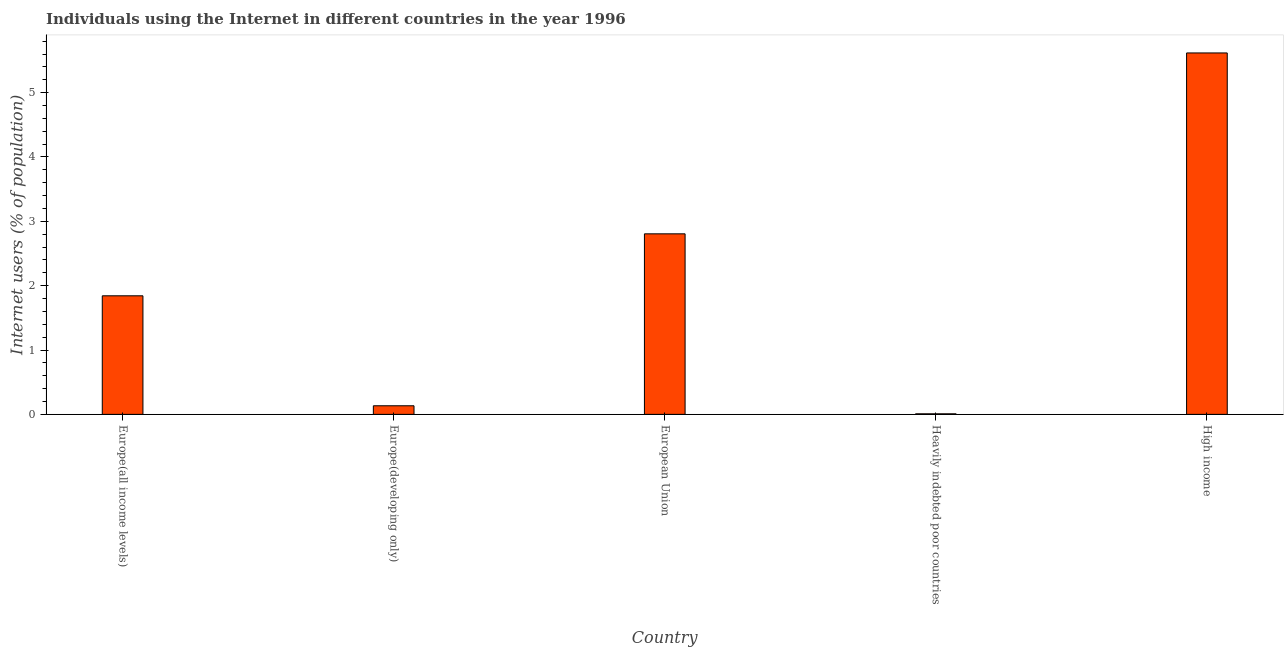Does the graph contain any zero values?
Make the answer very short. No. Does the graph contain grids?
Offer a terse response. No. What is the title of the graph?
Provide a short and direct response. Individuals using the Internet in different countries in the year 1996. What is the label or title of the Y-axis?
Provide a short and direct response. Internet users (% of population). What is the number of internet users in High income?
Your answer should be compact. 5.62. Across all countries, what is the maximum number of internet users?
Provide a succinct answer. 5.62. Across all countries, what is the minimum number of internet users?
Provide a succinct answer. 0.01. In which country was the number of internet users maximum?
Make the answer very short. High income. In which country was the number of internet users minimum?
Ensure brevity in your answer.  Heavily indebted poor countries. What is the sum of the number of internet users?
Provide a succinct answer. 10.41. What is the difference between the number of internet users in Europe(all income levels) and European Union?
Your answer should be compact. -0.96. What is the average number of internet users per country?
Make the answer very short. 2.08. What is the median number of internet users?
Keep it short and to the point. 1.84. What is the ratio of the number of internet users in Europe(all income levels) to that in Europe(developing only)?
Offer a very short reply. 13.8. Is the number of internet users in Europe(all income levels) less than that in High income?
Provide a short and direct response. Yes. What is the difference between the highest and the second highest number of internet users?
Provide a succinct answer. 2.81. Is the sum of the number of internet users in Europe(all income levels) and Europe(developing only) greater than the maximum number of internet users across all countries?
Your answer should be compact. No. What is the difference between the highest and the lowest number of internet users?
Ensure brevity in your answer.  5.61. Are the values on the major ticks of Y-axis written in scientific E-notation?
Your answer should be compact. No. What is the Internet users (% of population) of Europe(all income levels)?
Your response must be concise. 1.84. What is the Internet users (% of population) of Europe(developing only)?
Ensure brevity in your answer.  0.13. What is the Internet users (% of population) in European Union?
Your answer should be very brief. 2.81. What is the Internet users (% of population) of Heavily indebted poor countries?
Offer a terse response. 0.01. What is the Internet users (% of population) of High income?
Your answer should be compact. 5.62. What is the difference between the Internet users (% of population) in Europe(all income levels) and Europe(developing only)?
Your answer should be very brief. 1.71. What is the difference between the Internet users (% of population) in Europe(all income levels) and European Union?
Your response must be concise. -0.96. What is the difference between the Internet users (% of population) in Europe(all income levels) and Heavily indebted poor countries?
Give a very brief answer. 1.83. What is the difference between the Internet users (% of population) in Europe(all income levels) and High income?
Your response must be concise. -3.77. What is the difference between the Internet users (% of population) in Europe(developing only) and European Union?
Keep it short and to the point. -2.67. What is the difference between the Internet users (% of population) in Europe(developing only) and Heavily indebted poor countries?
Your answer should be compact. 0.12. What is the difference between the Internet users (% of population) in Europe(developing only) and High income?
Ensure brevity in your answer.  -5.48. What is the difference between the Internet users (% of population) in European Union and Heavily indebted poor countries?
Your answer should be compact. 2.8. What is the difference between the Internet users (% of population) in European Union and High income?
Keep it short and to the point. -2.81. What is the difference between the Internet users (% of population) in Heavily indebted poor countries and High income?
Your answer should be compact. -5.61. What is the ratio of the Internet users (% of population) in Europe(all income levels) to that in Europe(developing only)?
Keep it short and to the point. 13.8. What is the ratio of the Internet users (% of population) in Europe(all income levels) to that in European Union?
Give a very brief answer. 0.66. What is the ratio of the Internet users (% of population) in Europe(all income levels) to that in Heavily indebted poor countries?
Ensure brevity in your answer.  211.12. What is the ratio of the Internet users (% of population) in Europe(all income levels) to that in High income?
Give a very brief answer. 0.33. What is the ratio of the Internet users (% of population) in Europe(developing only) to that in European Union?
Provide a short and direct response. 0.05. What is the ratio of the Internet users (% of population) in Europe(developing only) to that in Heavily indebted poor countries?
Offer a terse response. 15.3. What is the ratio of the Internet users (% of population) in Europe(developing only) to that in High income?
Keep it short and to the point. 0.02. What is the ratio of the Internet users (% of population) in European Union to that in Heavily indebted poor countries?
Your response must be concise. 321.45. What is the ratio of the Internet users (% of population) in Heavily indebted poor countries to that in High income?
Your answer should be compact. 0. 